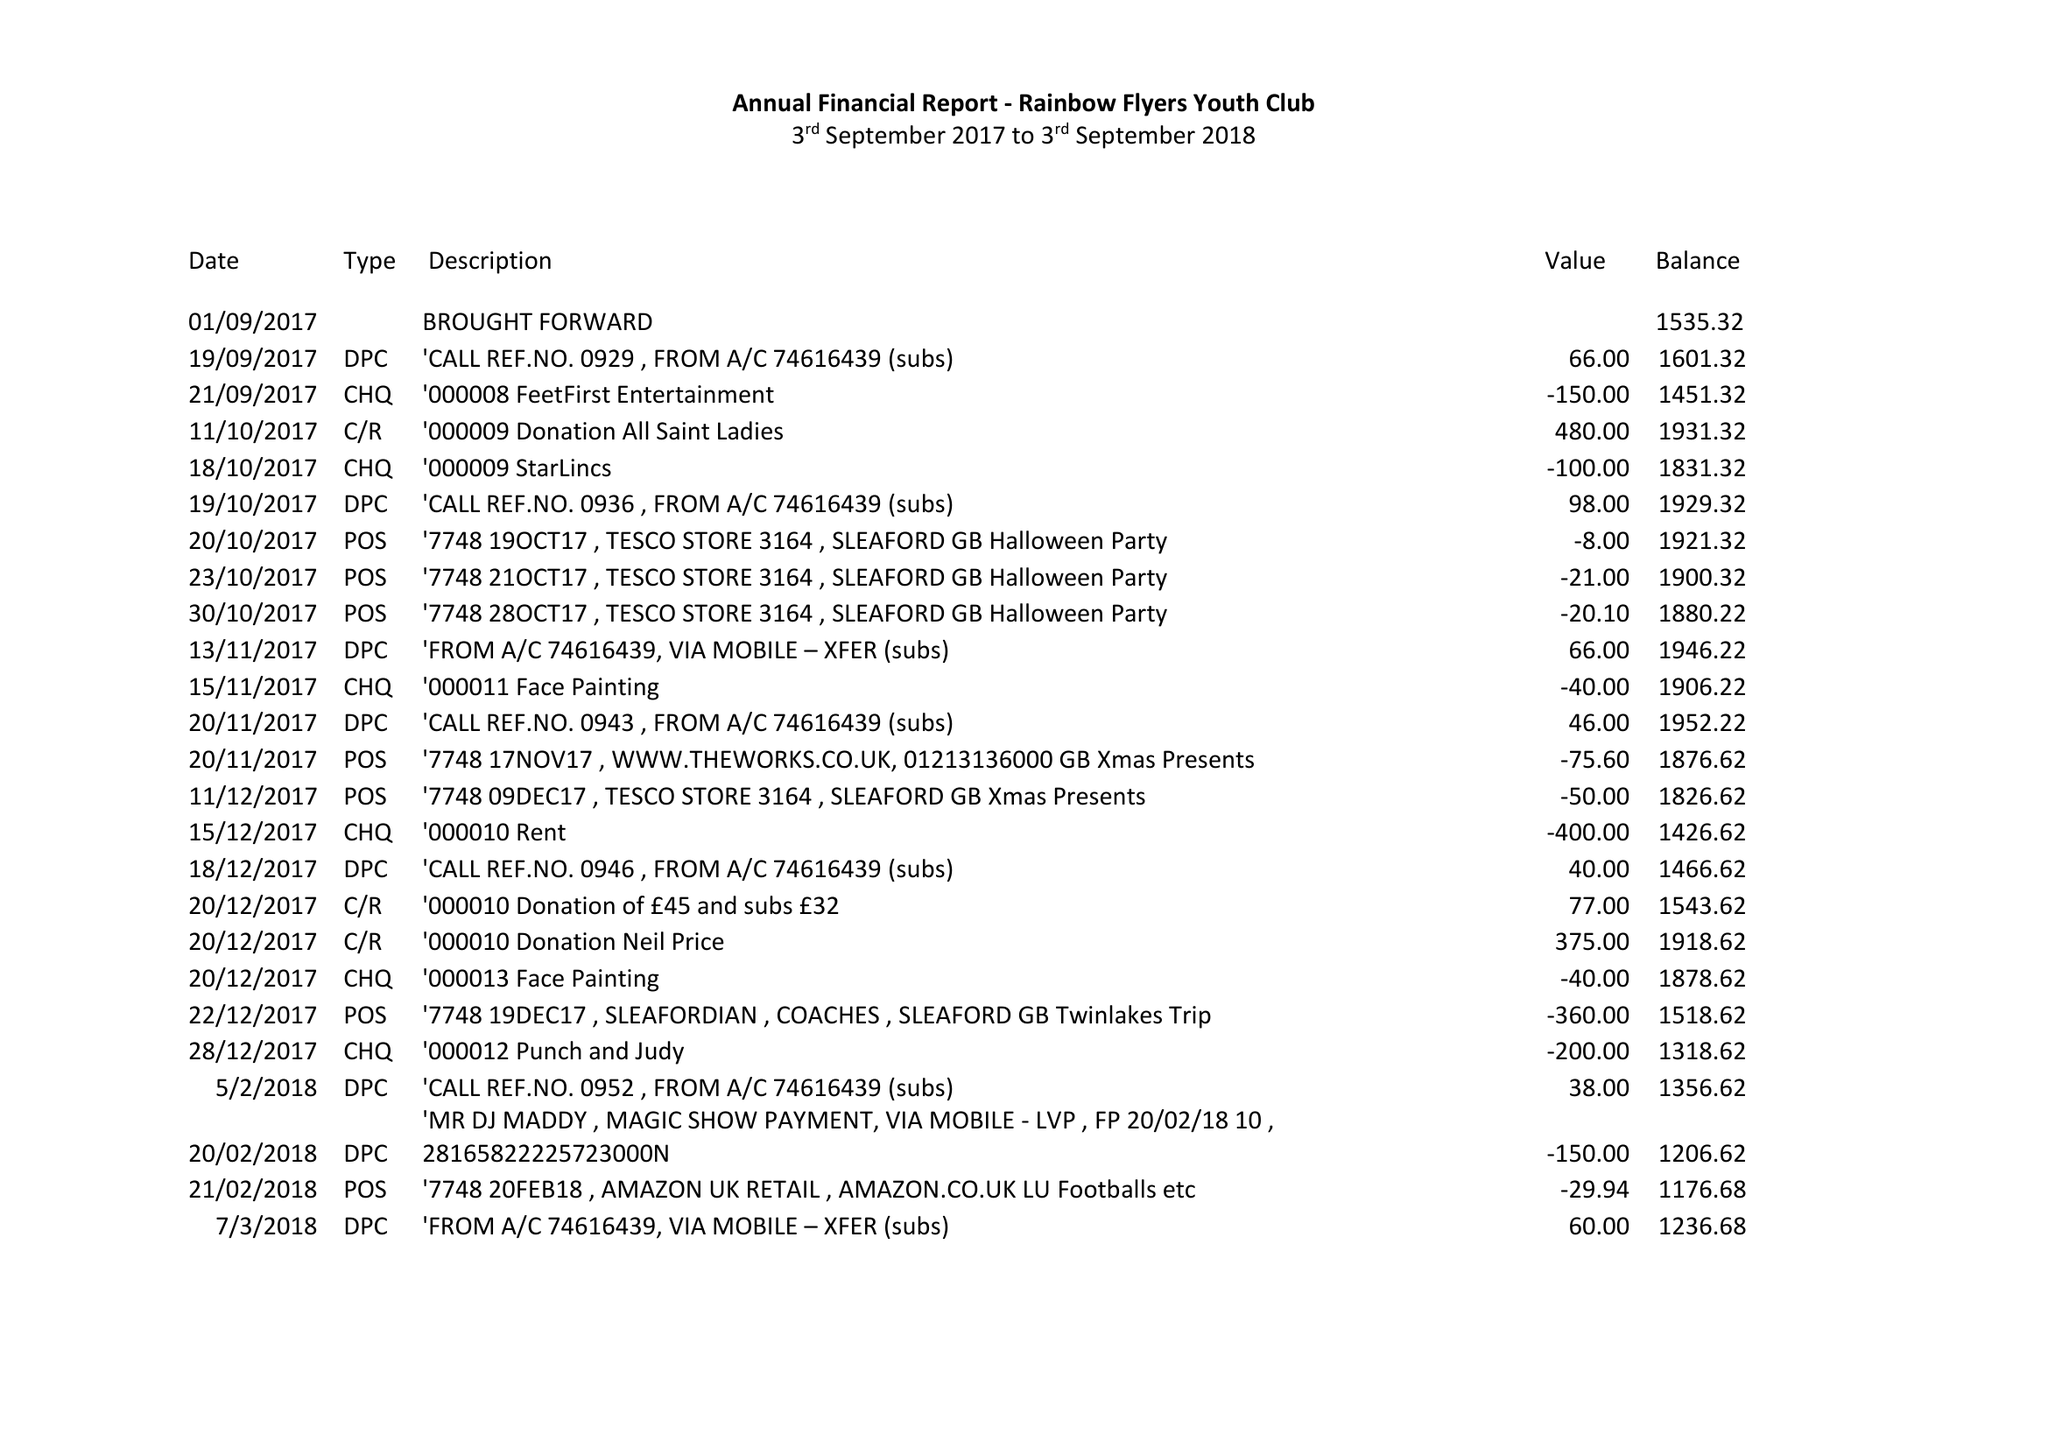What is the value for the report_date?
Answer the question using a single word or phrase. 2018-09-03 